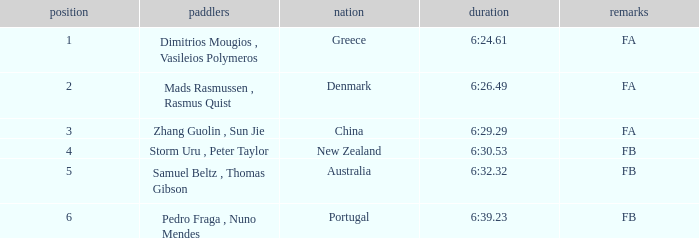Parse the table in full. {'header': ['position', 'paddlers', 'nation', 'duration', 'remarks'], 'rows': [['1', 'Dimitrios Mougios , Vasileios Polymeros', 'Greece', '6:24.61', 'FA'], ['2', 'Mads Rasmussen , Rasmus Quist', 'Denmark', '6:26.49', 'FA'], ['3', 'Zhang Guolin , Sun Jie', 'China', '6:29.29', 'FA'], ['4', 'Storm Uru , Peter Taylor', 'New Zealand', '6:30.53', 'FB'], ['5', 'Samuel Beltz , Thomas Gibson', 'Australia', '6:32.32', 'FB'], ['6', 'Pedro Fraga , Nuno Mendes', 'Portugal', '6:39.23', 'FB']]} What is the names of the rowers that the time was 6:24.61? Dimitrios Mougios , Vasileios Polymeros. 